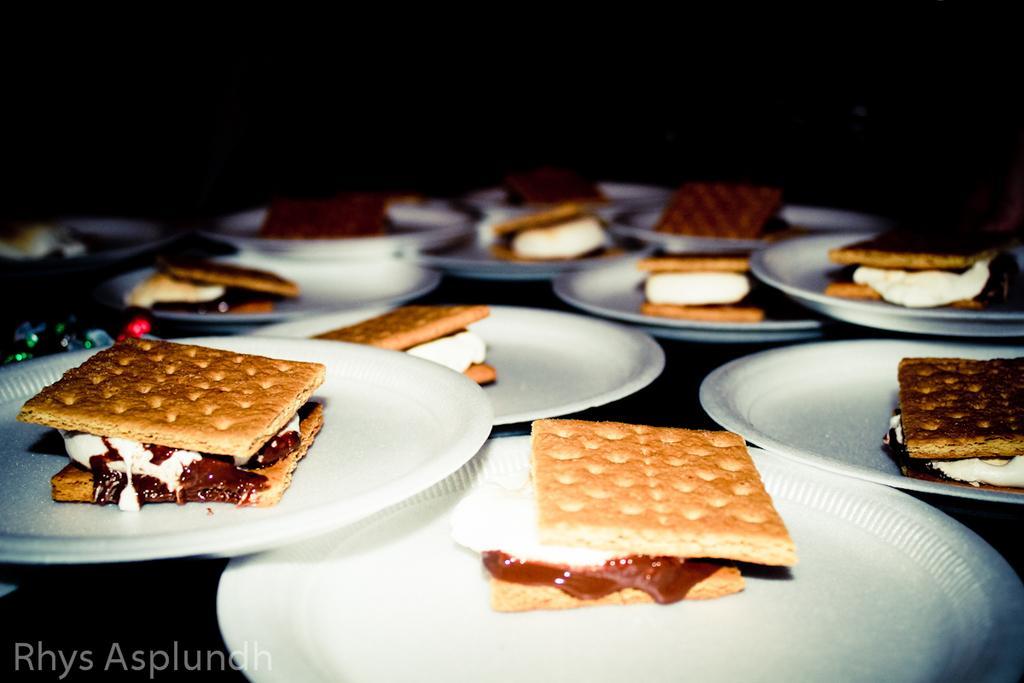Describe this image in one or two sentences. In the image in the center, we can see one table. On the table, we can see planets and some food items. In the bottom left of the image, there is a watermark. 